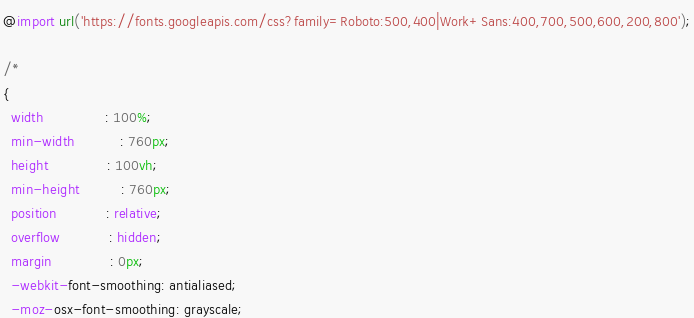Convert code to text. <code><loc_0><loc_0><loc_500><loc_500><_CSS_>@import url('https://fonts.googleapis.com/css?family=Roboto:500,400|Work+Sans:400,700,500,600,200,800');

/*
{
  width               : 100%;
  min-width           : 760px;
  height              : 100vh;
  min-height          : 760px;
  position            : relative;
  overflow            : hidden;
  margin              : 0px;
  -webkit-font-smoothing: antialiased;
  -moz-osx-font-smoothing: grayscale;</code> 